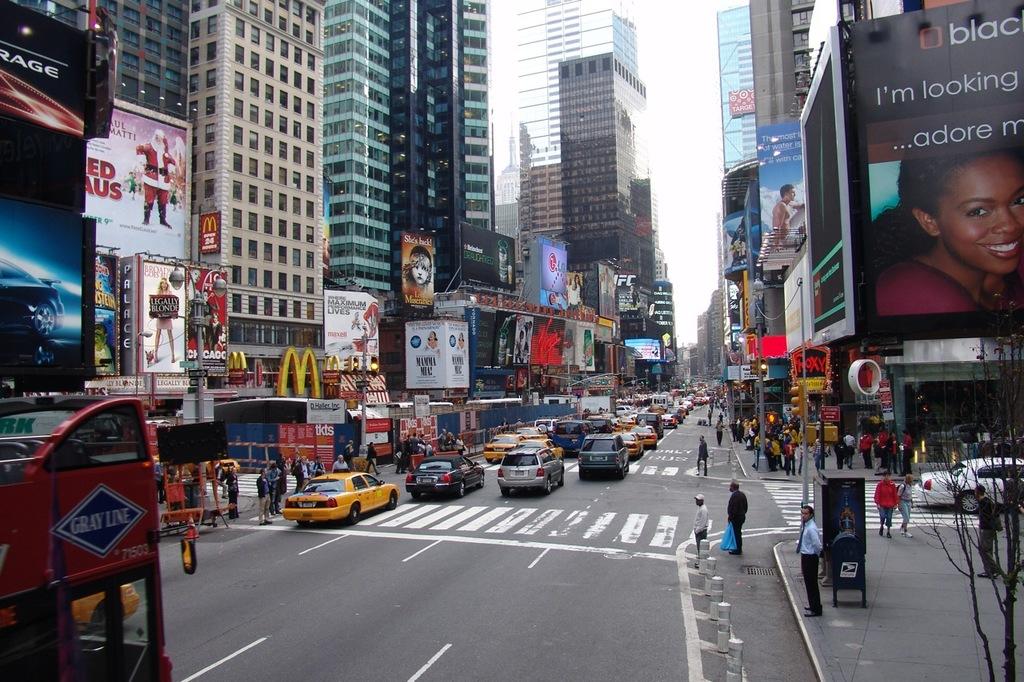Who is looking?
Ensure brevity in your answer.  I'm looking. What is in the blue diamond in the bottom left corner?
Your response must be concise. Gray line. 